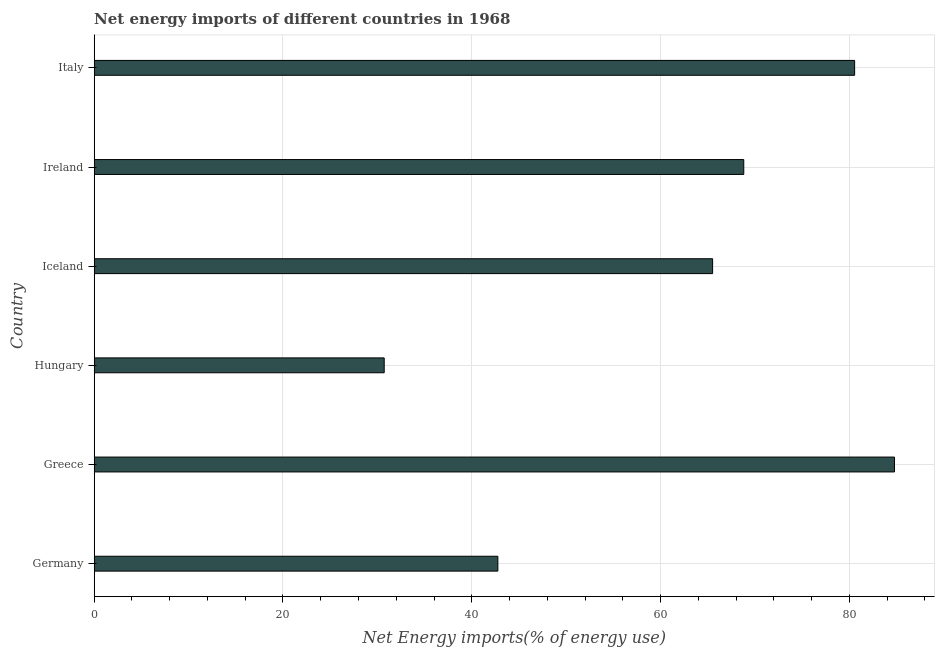Does the graph contain grids?
Your answer should be compact. Yes. What is the title of the graph?
Your response must be concise. Net energy imports of different countries in 1968. What is the label or title of the X-axis?
Offer a terse response. Net Energy imports(% of energy use). What is the label or title of the Y-axis?
Provide a succinct answer. Country. What is the energy imports in Ireland?
Give a very brief answer. 68.82. Across all countries, what is the maximum energy imports?
Offer a very short reply. 84.78. Across all countries, what is the minimum energy imports?
Make the answer very short. 30.72. In which country was the energy imports minimum?
Offer a terse response. Hungary. What is the sum of the energy imports?
Ensure brevity in your answer.  373.17. What is the difference between the energy imports in Greece and Iceland?
Make the answer very short. 19.27. What is the average energy imports per country?
Give a very brief answer. 62.2. What is the median energy imports?
Your response must be concise. 67.17. What is the ratio of the energy imports in Iceland to that in Ireland?
Your answer should be compact. 0.95. Is the energy imports in Greece less than that in Ireland?
Give a very brief answer. No. Is the difference between the energy imports in Germany and Greece greater than the difference between any two countries?
Ensure brevity in your answer.  No. What is the difference between the highest and the second highest energy imports?
Keep it short and to the point. 4.22. What is the difference between the highest and the lowest energy imports?
Provide a succinct answer. 54.06. In how many countries, is the energy imports greater than the average energy imports taken over all countries?
Your answer should be very brief. 4. How many bars are there?
Your response must be concise. 6. What is the difference between two consecutive major ticks on the X-axis?
Provide a succinct answer. 20. Are the values on the major ticks of X-axis written in scientific E-notation?
Ensure brevity in your answer.  No. What is the Net Energy imports(% of energy use) in Germany?
Ensure brevity in your answer.  42.77. What is the Net Energy imports(% of energy use) of Greece?
Provide a short and direct response. 84.78. What is the Net Energy imports(% of energy use) in Hungary?
Ensure brevity in your answer.  30.72. What is the Net Energy imports(% of energy use) of Iceland?
Make the answer very short. 65.52. What is the Net Energy imports(% of energy use) of Ireland?
Make the answer very short. 68.82. What is the Net Energy imports(% of energy use) of Italy?
Your answer should be very brief. 80.56. What is the difference between the Net Energy imports(% of energy use) in Germany and Greece?
Give a very brief answer. -42.02. What is the difference between the Net Energy imports(% of energy use) in Germany and Hungary?
Your answer should be very brief. 12.04. What is the difference between the Net Energy imports(% of energy use) in Germany and Iceland?
Your response must be concise. -22.75. What is the difference between the Net Energy imports(% of energy use) in Germany and Ireland?
Give a very brief answer. -26.05. What is the difference between the Net Energy imports(% of energy use) in Germany and Italy?
Provide a succinct answer. -37.8. What is the difference between the Net Energy imports(% of energy use) in Greece and Hungary?
Make the answer very short. 54.06. What is the difference between the Net Energy imports(% of energy use) in Greece and Iceland?
Offer a terse response. 19.27. What is the difference between the Net Energy imports(% of energy use) in Greece and Ireland?
Keep it short and to the point. 15.97. What is the difference between the Net Energy imports(% of energy use) in Greece and Italy?
Offer a terse response. 4.22. What is the difference between the Net Energy imports(% of energy use) in Hungary and Iceland?
Your answer should be very brief. -34.79. What is the difference between the Net Energy imports(% of energy use) in Hungary and Ireland?
Ensure brevity in your answer.  -38.09. What is the difference between the Net Energy imports(% of energy use) in Hungary and Italy?
Provide a short and direct response. -49.84. What is the difference between the Net Energy imports(% of energy use) in Iceland and Ireland?
Your answer should be very brief. -3.3. What is the difference between the Net Energy imports(% of energy use) in Iceland and Italy?
Offer a terse response. -15.05. What is the difference between the Net Energy imports(% of energy use) in Ireland and Italy?
Give a very brief answer. -11.74. What is the ratio of the Net Energy imports(% of energy use) in Germany to that in Greece?
Ensure brevity in your answer.  0.5. What is the ratio of the Net Energy imports(% of energy use) in Germany to that in Hungary?
Ensure brevity in your answer.  1.39. What is the ratio of the Net Energy imports(% of energy use) in Germany to that in Iceland?
Give a very brief answer. 0.65. What is the ratio of the Net Energy imports(% of energy use) in Germany to that in Ireland?
Keep it short and to the point. 0.62. What is the ratio of the Net Energy imports(% of energy use) in Germany to that in Italy?
Keep it short and to the point. 0.53. What is the ratio of the Net Energy imports(% of energy use) in Greece to that in Hungary?
Provide a succinct answer. 2.76. What is the ratio of the Net Energy imports(% of energy use) in Greece to that in Iceland?
Give a very brief answer. 1.29. What is the ratio of the Net Energy imports(% of energy use) in Greece to that in Ireland?
Provide a succinct answer. 1.23. What is the ratio of the Net Energy imports(% of energy use) in Greece to that in Italy?
Provide a short and direct response. 1.05. What is the ratio of the Net Energy imports(% of energy use) in Hungary to that in Iceland?
Provide a short and direct response. 0.47. What is the ratio of the Net Energy imports(% of energy use) in Hungary to that in Ireland?
Provide a succinct answer. 0.45. What is the ratio of the Net Energy imports(% of energy use) in Hungary to that in Italy?
Keep it short and to the point. 0.38. What is the ratio of the Net Energy imports(% of energy use) in Iceland to that in Ireland?
Your answer should be compact. 0.95. What is the ratio of the Net Energy imports(% of energy use) in Iceland to that in Italy?
Give a very brief answer. 0.81. What is the ratio of the Net Energy imports(% of energy use) in Ireland to that in Italy?
Your answer should be very brief. 0.85. 